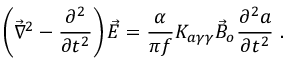Convert formula to latex. <formula><loc_0><loc_0><loc_500><loc_500>\left ( \vec { \nabla } ^ { 2 } - \frac { \partial ^ { 2 } } { \partial t ^ { 2 } } \right ) \vec { E } = \frac { \alpha } { \pi f } K _ { a \gamma \gamma } \vec { B } _ { o } \frac { \partial ^ { 2 } a } { \partial t ^ { 2 } } .</formula> 